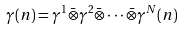Convert formula to latex. <formula><loc_0><loc_0><loc_500><loc_500>\gamma ( n ) = \gamma ^ { 1 } \bar { \otimes } \gamma ^ { 2 } \bar { \otimes } \cdot \cdot \cdot \bar { \otimes } \gamma ^ { N } ( n )</formula> 